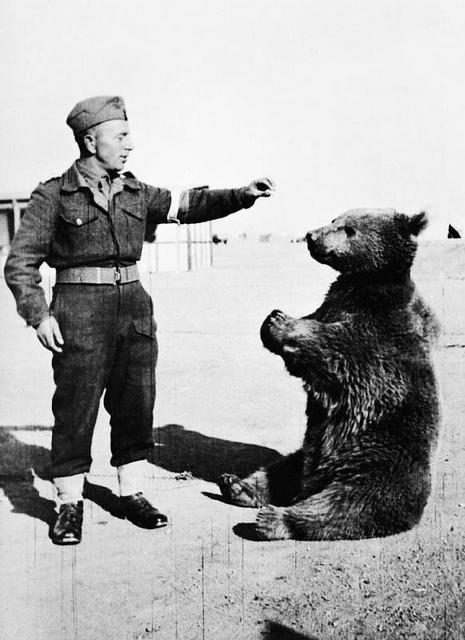How many birds are in the picture?
Give a very brief answer. 0. 